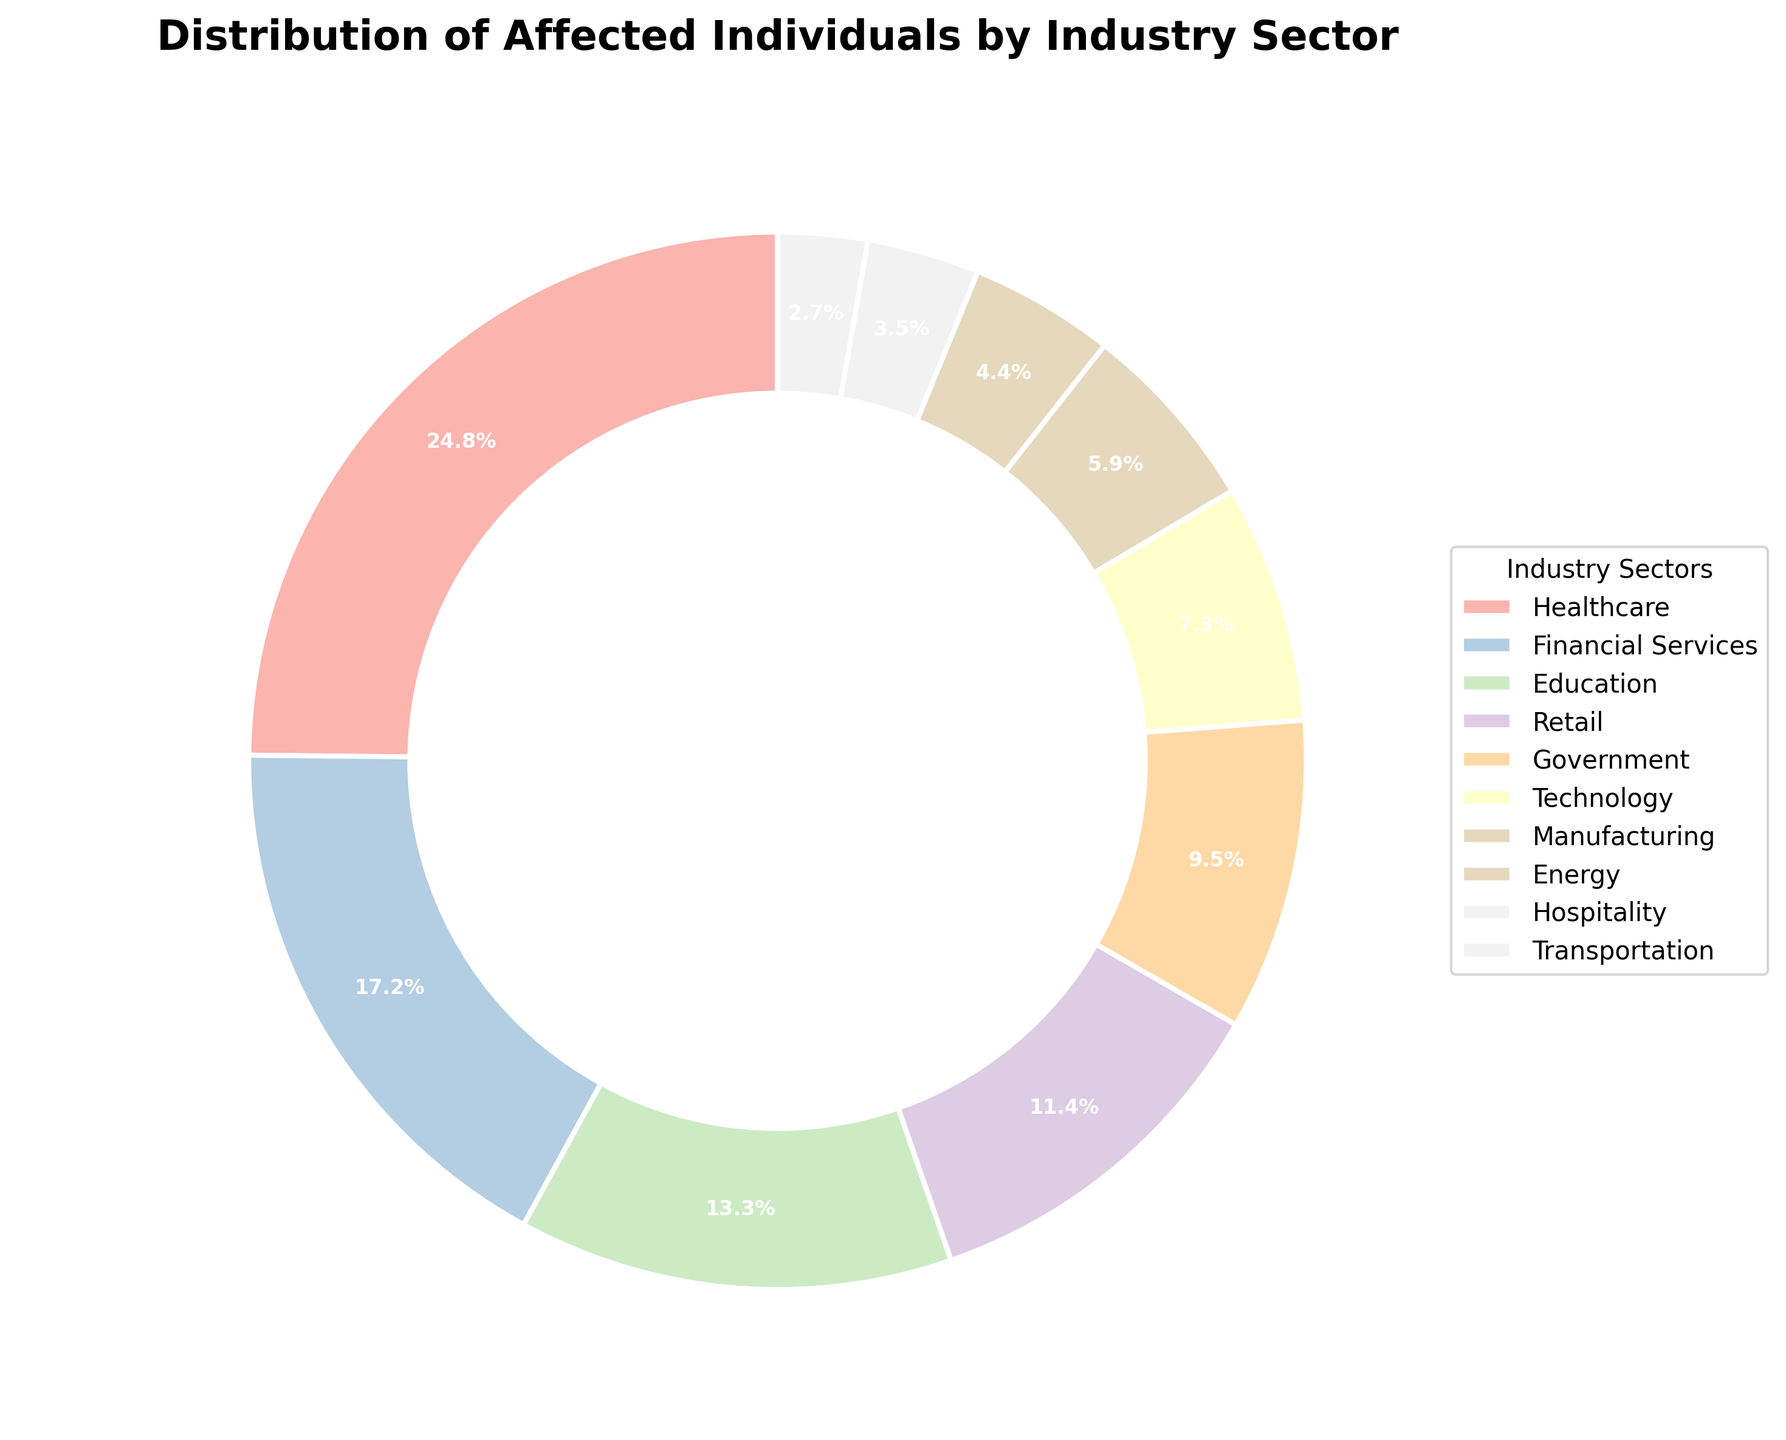Which industry sector has the highest number of affected individuals? The pie chart shows that the Healthcare sector has the largest portion of the pie.
Answer: Healthcare What is the total number of affected individuals across all sectors? Adding up the number of affected individuals in each sector: 142500 (Healthcare) + 98700 (Financial Services) + 76300 (Education) + 65200 (Retail) + 54800 (Government) + 41900 (Technology) + 33600 (Manufacturing) + 25400 (Energy) + 19800 (Hospitality) + 15700 (Transportation) = 453900.
Answer: 453900 Which industry has more affected individuals, Financial Services or Education? The Financial Services sector affects 98700 individuals, which is more than the Education sector's 76300.
Answer: Financial Services What is the sum of the affected individuals in the Government and Technology sectors? Adding the numbers for Government (54800) and Technology (41900): 54800 + 41900 = 96700.
Answer: 96700 Which industry has the fewest affected individuals? The pie chart shows that Transportation has the smallest portion.
Answer: Transportation Out of the top three most affected sectors, which one has the fewest affected individuals? The top three sectors by affected individuals are Healthcare (142500), Financial Services (98700), and Education (76300). The sector with the fewest among these three is Education.
Answer: Education What is the difference in the number of affected individuals between the Retail and Energy sectors? Subtracting Energy (25400) from Retail (65200): 65200 - 25400 = 39800.
Answer: 39800 What percentage of affected individuals comes from the Manufacturing sector? The pie chart indicates the proportion of the Manufacturing sector among all affected individuals; the label on the Manufacturing sector's slice shows 7.4%.
Answer: 7.4% If we combine the affected individuals from the Hospitality and Transportation sectors, what is their combined percentage of the total? The combined number is 19800 (Hospitality) + 15700 (Transportation) = 35500. The percentage is (35500 / 453900) * 100, which is approximately 7.8%.
Answer: 7.8% Which sector among Technology and Energy has a larger share of the affected individuals? The Technology sector affects 41900 individuals, whereas the Energy sector affects 25400. Technology has a larger share.
Answer: Technology 